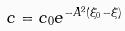<formula> <loc_0><loc_0><loc_500><loc_500>c = c _ { 0 } e ^ { - A ^ { 2 } ( \xi _ { 0 } - \xi ) }</formula> 